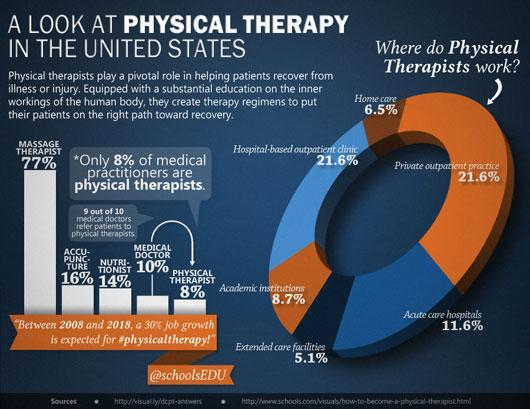What is the percentage of accupuncture practitioners?
Answer the question with a short phrase. 16% What percentage of physical therapists work in home care and extended care facilities? 11.6% 